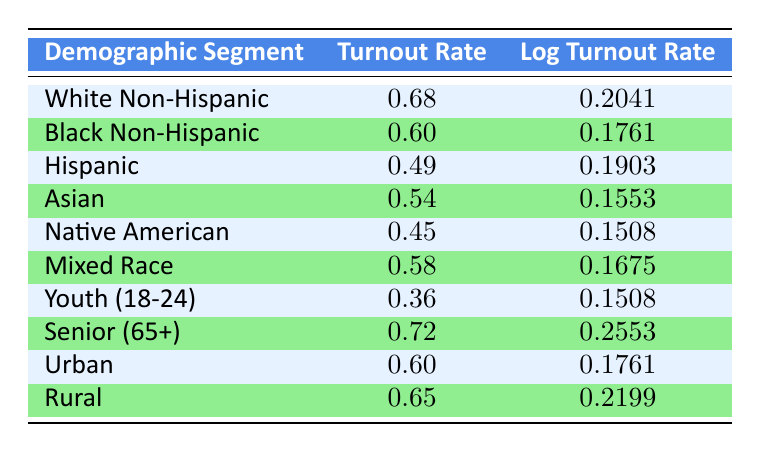What is the turnout rate for Seniors (65+)? The turnout rate for Seniors (65+) is found directly in the table under the "Turnout Rate" column for the demographic segment "Senior (65+)", which shows a value of 0.72.
Answer: 0.72 What is the log turnout rate for the Hispanic demographic? The log turnout rate for the Hispanic demographic can be found directly in the table in the corresponding row, where it shows a value of 0.1903 under "Log Turnout Rate".
Answer: 0.1903 Which demographic segments have a turnout rate of 60% or higher? Looking through the table, the segments with a turnout rate of 0.60 or higher are: White Non-Hispanic (0.68), Black Non-Hispanic (0.60), Senior (65+) (0.72), Urban (0.60), and Rural (0.65).
Answer: White Non-Hispanic, Black Non-Hispanic, Senior (65+), Urban, Rural What is the difference in turnout rates between the White Non-Hispanic and Native American demographics? The turnout rate for White Non-Hispanic is 0.68, while for Native American, it is 0.45. The difference is 0.68 - 0.45 = 0.23.
Answer: 0.23 Is the turnout rate for Youth (18-24) higher than that of Native American? The turnout rate for Youth (18-24) is 0.36 and for Native American, it is 0.45. Since 0.36 is less than 0.45, the statement is false.
Answer: No What is the average turnout rate for both Urban and Rural demographics? The turnout rate for Urban is 0.60 and for Rural is 0.65. The average is calculated as (0.60 + 0.65) / 2 = 0.625.
Answer: 0.625 Do Black Non-Hispanic voters have a higher log turnout rate than Asian voters? The log turnout rate for Black Non-Hispanic is 0.1761, and for Asian, it is 0.1553. Since 0.1761 is greater than 0.1553, the statement is true.
Answer: Yes Which demographic has the lowest turnout rate? By scanning the table, the demographic with the lowest turnout rate is Youth (18-24) at 0.36.
Answer: Youth (18-24) 